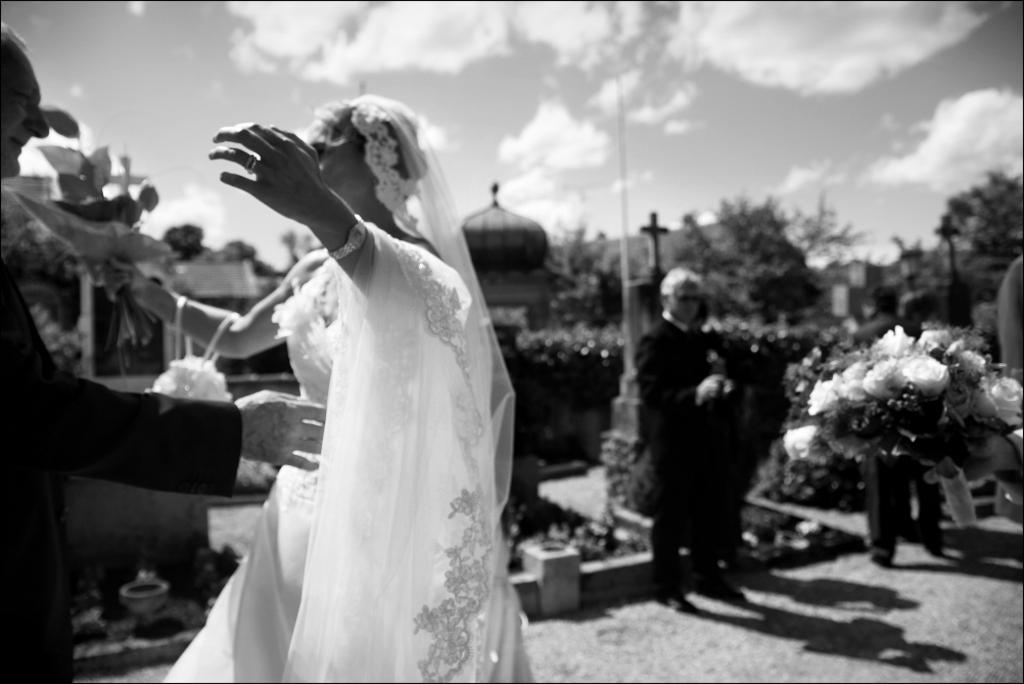Could you give a brief overview of what you see in this image? In this image I can see the black and white picture of a person wearing black dress and a woman wearing white colored dress are standing. In the ground I can see a person standing, a flower bouquet, few buildings, few trees and the sky. 